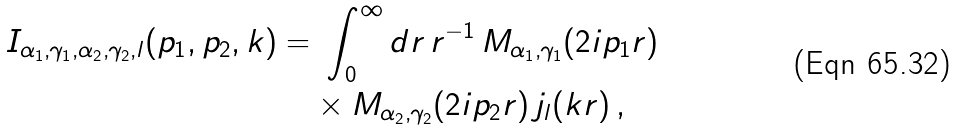<formula> <loc_0><loc_0><loc_500><loc_500>I _ { \alpha _ { 1 } , \gamma _ { 1 } , \alpha _ { 2 } , \gamma _ { 2 } , l } ( p _ { 1 } , p _ { 2 } , k ) = & \ \int _ { 0 } ^ { \infty } d r \, r ^ { - 1 } \, M _ { \alpha _ { 1 } , \gamma _ { 1 } } ( 2 i p _ { 1 } r ) \, \\ & \times M _ { \alpha _ { 2 } , \gamma _ { 2 } } ( 2 i p _ { 2 } r ) \, j _ { l } ( k r ) \, ,</formula> 